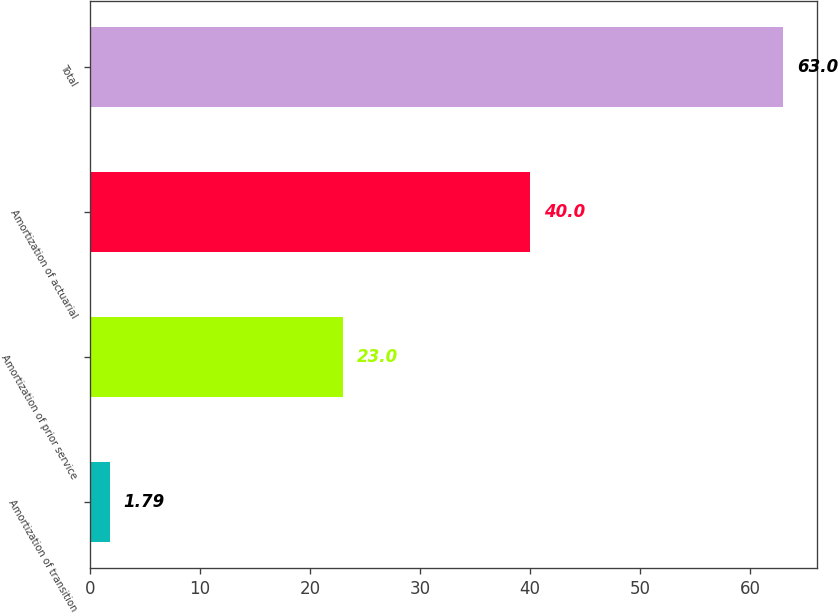<chart> <loc_0><loc_0><loc_500><loc_500><bar_chart><fcel>Amortization of transition<fcel>Amortization of prior service<fcel>Amortization of actuarial<fcel>Total<nl><fcel>1.79<fcel>23<fcel>40<fcel>63<nl></chart> 